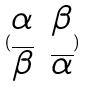<formula> <loc_0><loc_0><loc_500><loc_500>( \begin{matrix} \alpha & \beta \\ \overline { \beta } & \overline { \alpha } \end{matrix} )</formula> 